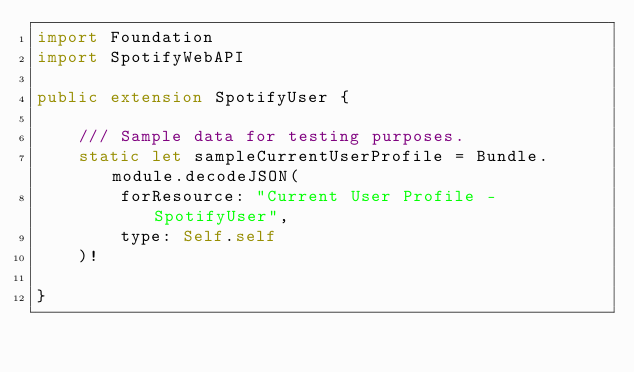Convert code to text. <code><loc_0><loc_0><loc_500><loc_500><_Swift_>import Foundation
import SpotifyWebAPI

public extension SpotifyUser {
    
    /// Sample data for testing purposes.
    static let sampleCurrentUserProfile = Bundle.module.decodeJSON(
        forResource: "Current User Profile - SpotifyUser",
        type: Self.self
    )!

}
</code> 